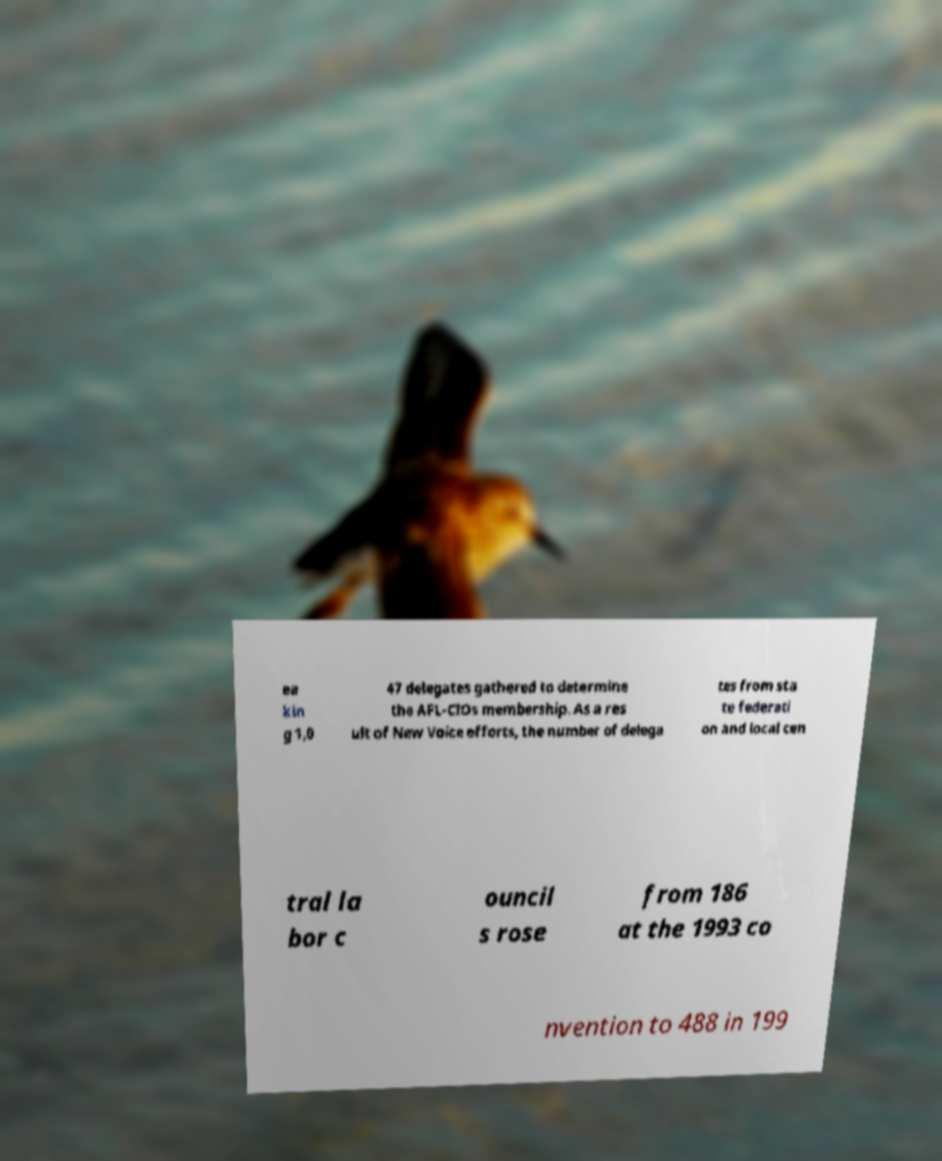Can you read and provide the text displayed in the image?This photo seems to have some interesting text. Can you extract and type it out for me? ea kin g 1,0 47 delegates gathered to determine the AFL-CIOs membership. As a res ult of New Voice efforts, the number of delega tes from sta te federati on and local cen tral la bor c ouncil s rose from 186 at the 1993 co nvention to 488 in 199 